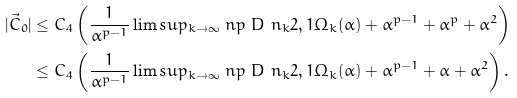<formula> <loc_0><loc_0><loc_500><loc_500>| \vec { C } _ { 0 } | & \leq C _ { 4 } \left ( \frac { 1 } { \alpha ^ { p - 1 } } \lim s u p _ { k \rightarrow \infty } \ n p { \ D \ n _ { k } } { 2 , 1 } { \Omega _ { k } ( \alpha ) } + \alpha ^ { p - 1 } + \alpha ^ { p } + \alpha ^ { 2 } \right ) \\ & \leq C _ { 4 } \left ( \frac { 1 } { \alpha ^ { p - 1 } } \lim s u p _ { k \rightarrow \infty } \ n p { \ D \ n _ { k } } { 2 , 1 } { \Omega _ { k } ( \alpha ) } + \alpha ^ { p - 1 } + \alpha + \alpha ^ { 2 } \right ) .</formula> 